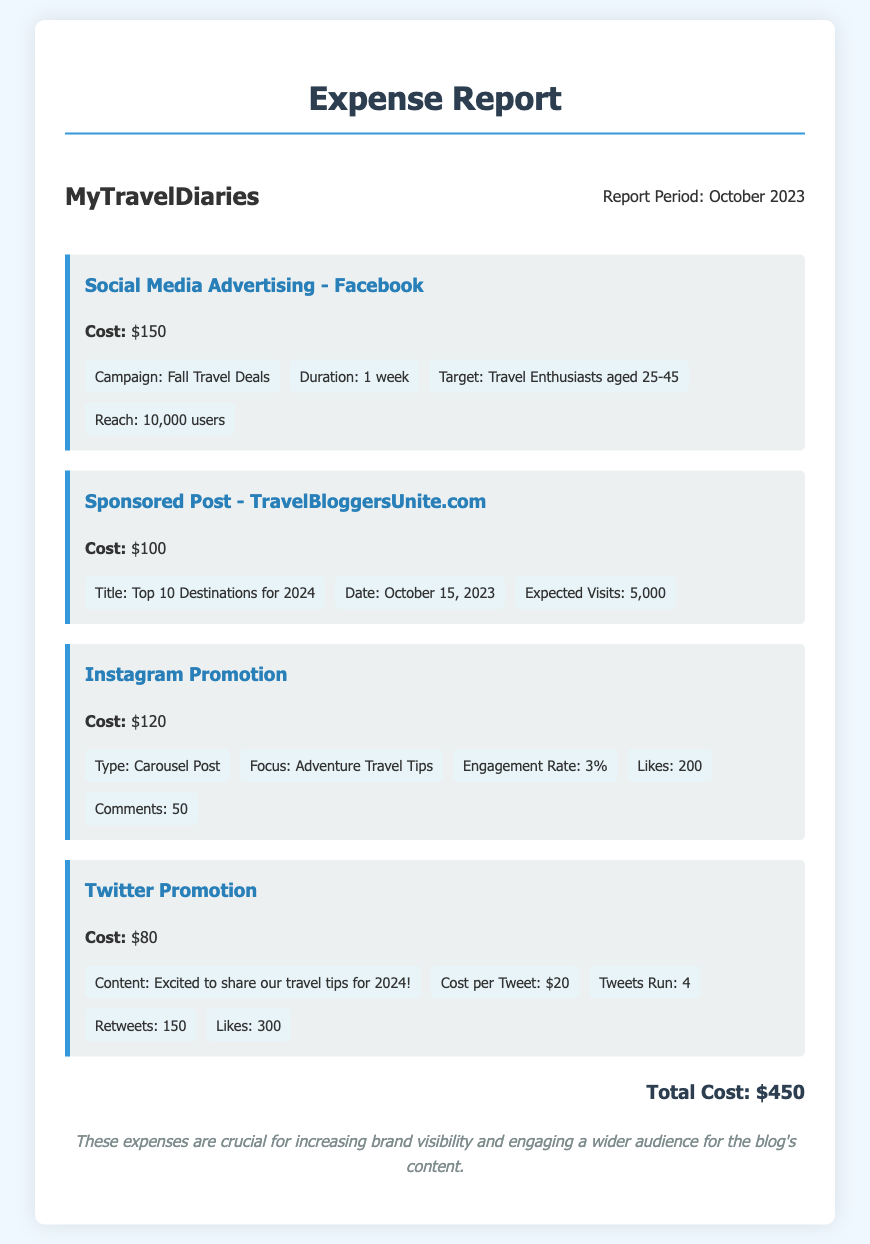What is the total cost? The total cost is the sum of all individual expenses listed in the document, which is $150 + $100 + $120 + $80 = $450.
Answer: $450 What is the cost of the Facebook advertising? The document specifically states the cost associated with Facebook advertising.
Answer: $150 What is the date of the sponsored post? The document provides the date for the sponsored post activity.
Answer: October 15, 2023 How many users did the Facebook campaign reach? This information is explicitly stated under the details of the Facebook advertising section.
Answer: 10,000 users What is the engagement rate for the Instagram promotion? The document includes the engagement rate for the Instagram promotion in the details.
Answer: 3% What type of tweet was promoted on Twitter? The document specifies the content of the promoted tweets in the Twitter promotion section.
Answer: Excited to share our travel tips for 2024! What was the title of the sponsored post? The title is mentioned in the sponsored post section of the document.
Answer: Top 10 Destinations for 2024 What was the reach of the Instagram promotion? While it mentions likes and comments, the document does not specify a reach for Instagram promotion.
Answer: Not mentioned 